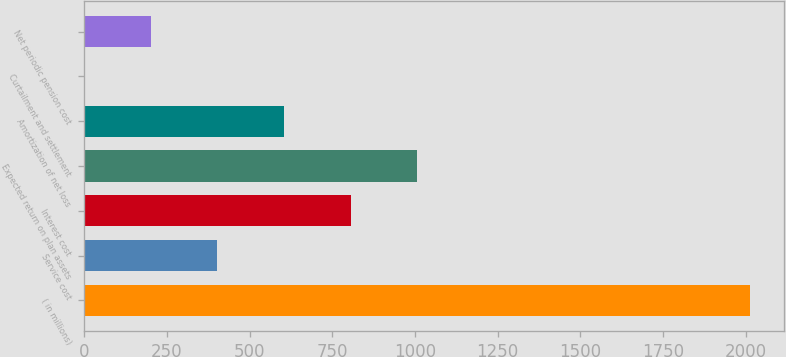Convert chart. <chart><loc_0><loc_0><loc_500><loc_500><bar_chart><fcel>( in millions)<fcel>Service cost<fcel>Interest cost<fcel>Expected return on plan assets<fcel>Amortization of net loss<fcel>Curtailment and settlement<fcel>Net periodic pension cost<nl><fcel>2014<fcel>402.96<fcel>805.72<fcel>1007.1<fcel>604.34<fcel>0.2<fcel>201.58<nl></chart> 